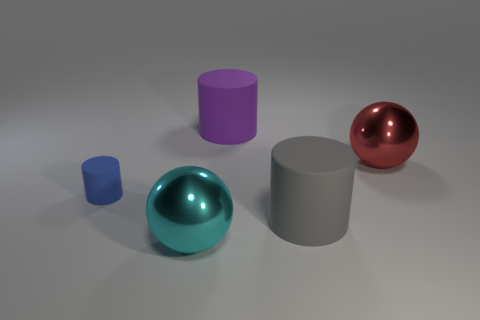Subtract all purple cylinders. How many cylinders are left? 2 Add 1 tiny cylinders. How many objects exist? 6 Subtract all blue cylinders. How many cylinders are left? 2 Subtract 1 red balls. How many objects are left? 4 Subtract all spheres. How many objects are left? 3 Subtract 2 cylinders. How many cylinders are left? 1 Subtract all yellow cylinders. Subtract all red blocks. How many cylinders are left? 3 Subtract all tiny rubber things. Subtract all small blue things. How many objects are left? 3 Add 5 small blue rubber cylinders. How many small blue rubber cylinders are left? 6 Add 3 tiny blue objects. How many tiny blue objects exist? 4 